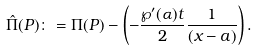<formula> <loc_0><loc_0><loc_500><loc_500>\hat { \Pi } ( P ) \colon = \Pi ( P ) - \left ( - \frac { \wp ^ { \prime } ( \alpha ) t } { 2 } \frac { 1 } { ( x - a ) } \right ) .</formula> 